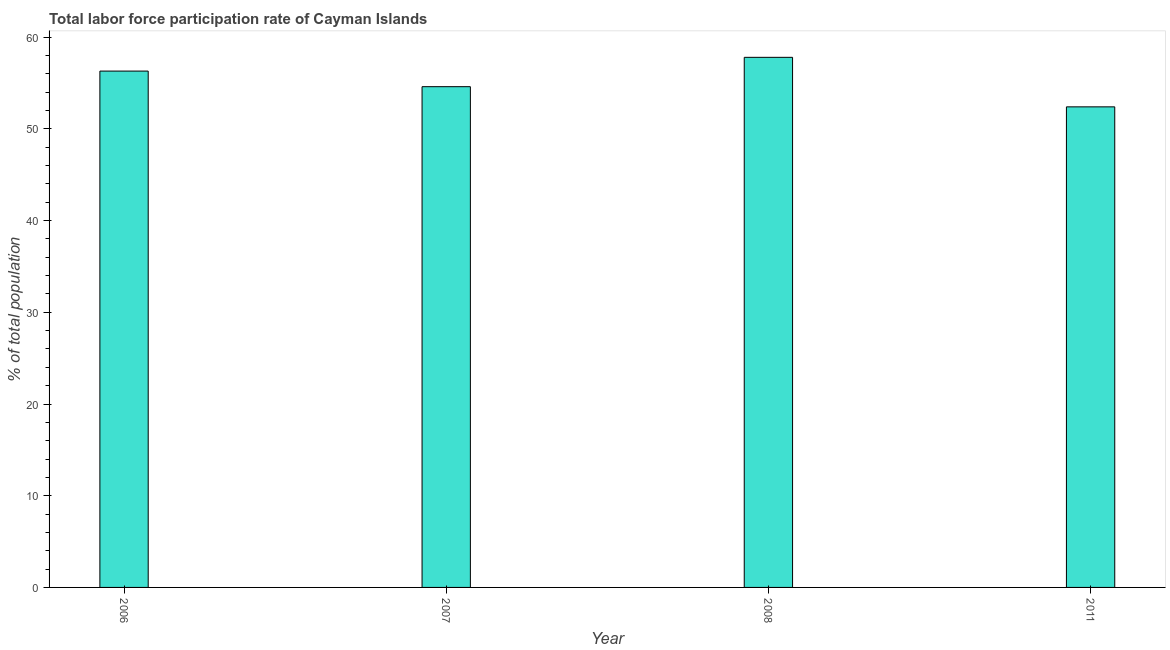Does the graph contain grids?
Give a very brief answer. No. What is the title of the graph?
Provide a short and direct response. Total labor force participation rate of Cayman Islands. What is the label or title of the Y-axis?
Offer a very short reply. % of total population. What is the total labor force participation rate in 2011?
Offer a terse response. 52.4. Across all years, what is the maximum total labor force participation rate?
Offer a very short reply. 57.8. Across all years, what is the minimum total labor force participation rate?
Offer a terse response. 52.4. What is the sum of the total labor force participation rate?
Your answer should be very brief. 221.1. What is the difference between the total labor force participation rate in 2006 and 2007?
Your answer should be compact. 1.7. What is the average total labor force participation rate per year?
Offer a very short reply. 55.27. What is the median total labor force participation rate?
Your answer should be very brief. 55.45. What is the ratio of the total labor force participation rate in 2006 to that in 2007?
Provide a succinct answer. 1.03. Is the difference between the total labor force participation rate in 2006 and 2007 greater than the difference between any two years?
Make the answer very short. No. What is the difference between the highest and the second highest total labor force participation rate?
Offer a very short reply. 1.5. What is the difference between the highest and the lowest total labor force participation rate?
Make the answer very short. 5.4. In how many years, is the total labor force participation rate greater than the average total labor force participation rate taken over all years?
Your answer should be very brief. 2. How many years are there in the graph?
Ensure brevity in your answer.  4. What is the difference between two consecutive major ticks on the Y-axis?
Offer a terse response. 10. What is the % of total population of 2006?
Offer a terse response. 56.3. What is the % of total population of 2007?
Give a very brief answer. 54.6. What is the % of total population in 2008?
Provide a succinct answer. 57.8. What is the % of total population of 2011?
Your answer should be compact. 52.4. What is the difference between the % of total population in 2006 and 2007?
Ensure brevity in your answer.  1.7. What is the difference between the % of total population in 2006 and 2011?
Provide a succinct answer. 3.9. What is the difference between the % of total population in 2008 and 2011?
Ensure brevity in your answer.  5.4. What is the ratio of the % of total population in 2006 to that in 2007?
Your answer should be compact. 1.03. What is the ratio of the % of total population in 2006 to that in 2008?
Your answer should be very brief. 0.97. What is the ratio of the % of total population in 2006 to that in 2011?
Your answer should be very brief. 1.07. What is the ratio of the % of total population in 2007 to that in 2008?
Give a very brief answer. 0.94. What is the ratio of the % of total population in 2007 to that in 2011?
Your answer should be very brief. 1.04. What is the ratio of the % of total population in 2008 to that in 2011?
Keep it short and to the point. 1.1. 